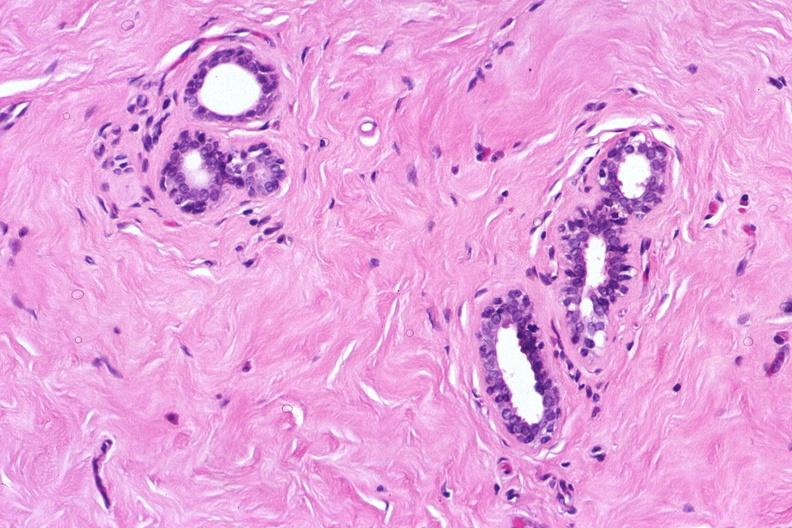does this image show normal breast?
Answer the question using a single word or phrase. Yes 